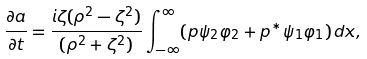Convert formula to latex. <formula><loc_0><loc_0><loc_500><loc_500>\frac { \partial a } { \partial t } = \frac { i \zeta ( \rho ^ { 2 } - \zeta ^ { 2 } ) } { ( \rho ^ { 2 } + \zeta ^ { 2 } ) } \int _ { - \infty } ^ { \infty } ( p \psi _ { 2 } \varphi _ { 2 } + p ^ { \ast } \psi _ { 1 } \varphi _ { 1 } ) \, d x ,</formula> 